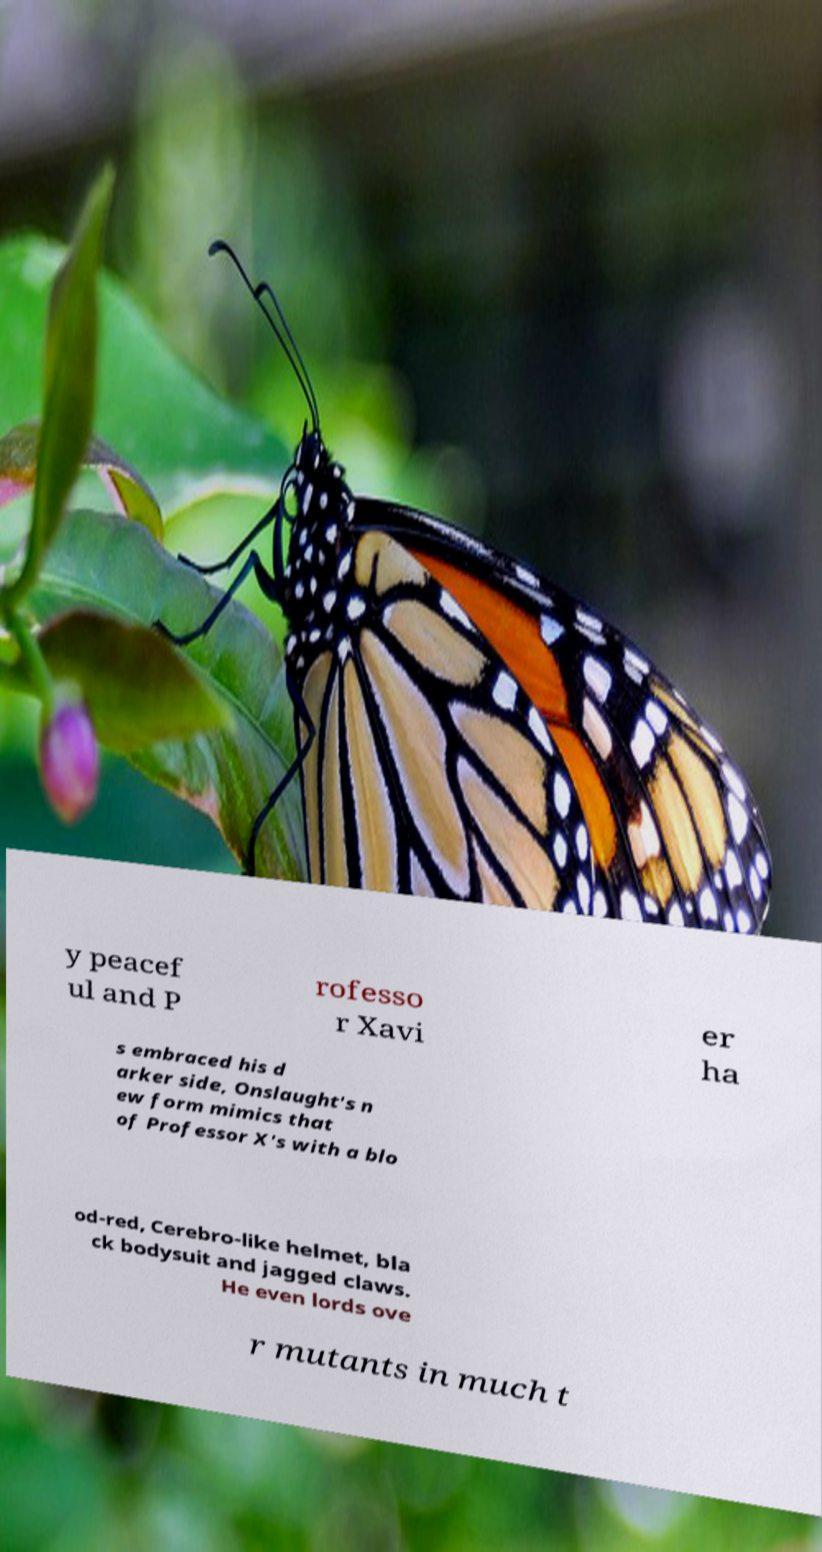Could you extract and type out the text from this image? y peacef ul and P rofesso r Xavi er ha s embraced his d arker side, Onslaught's n ew form mimics that of Professor X's with a blo od-red, Cerebro-like helmet, bla ck bodysuit and jagged claws. He even lords ove r mutants in much t 